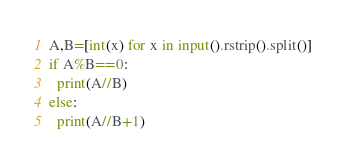<code> <loc_0><loc_0><loc_500><loc_500><_Python_>A,B=[int(x) for x in input().rstrip().split()]
if A%B==0:
  print(A//B)
else:
  print(A//B+1)</code> 